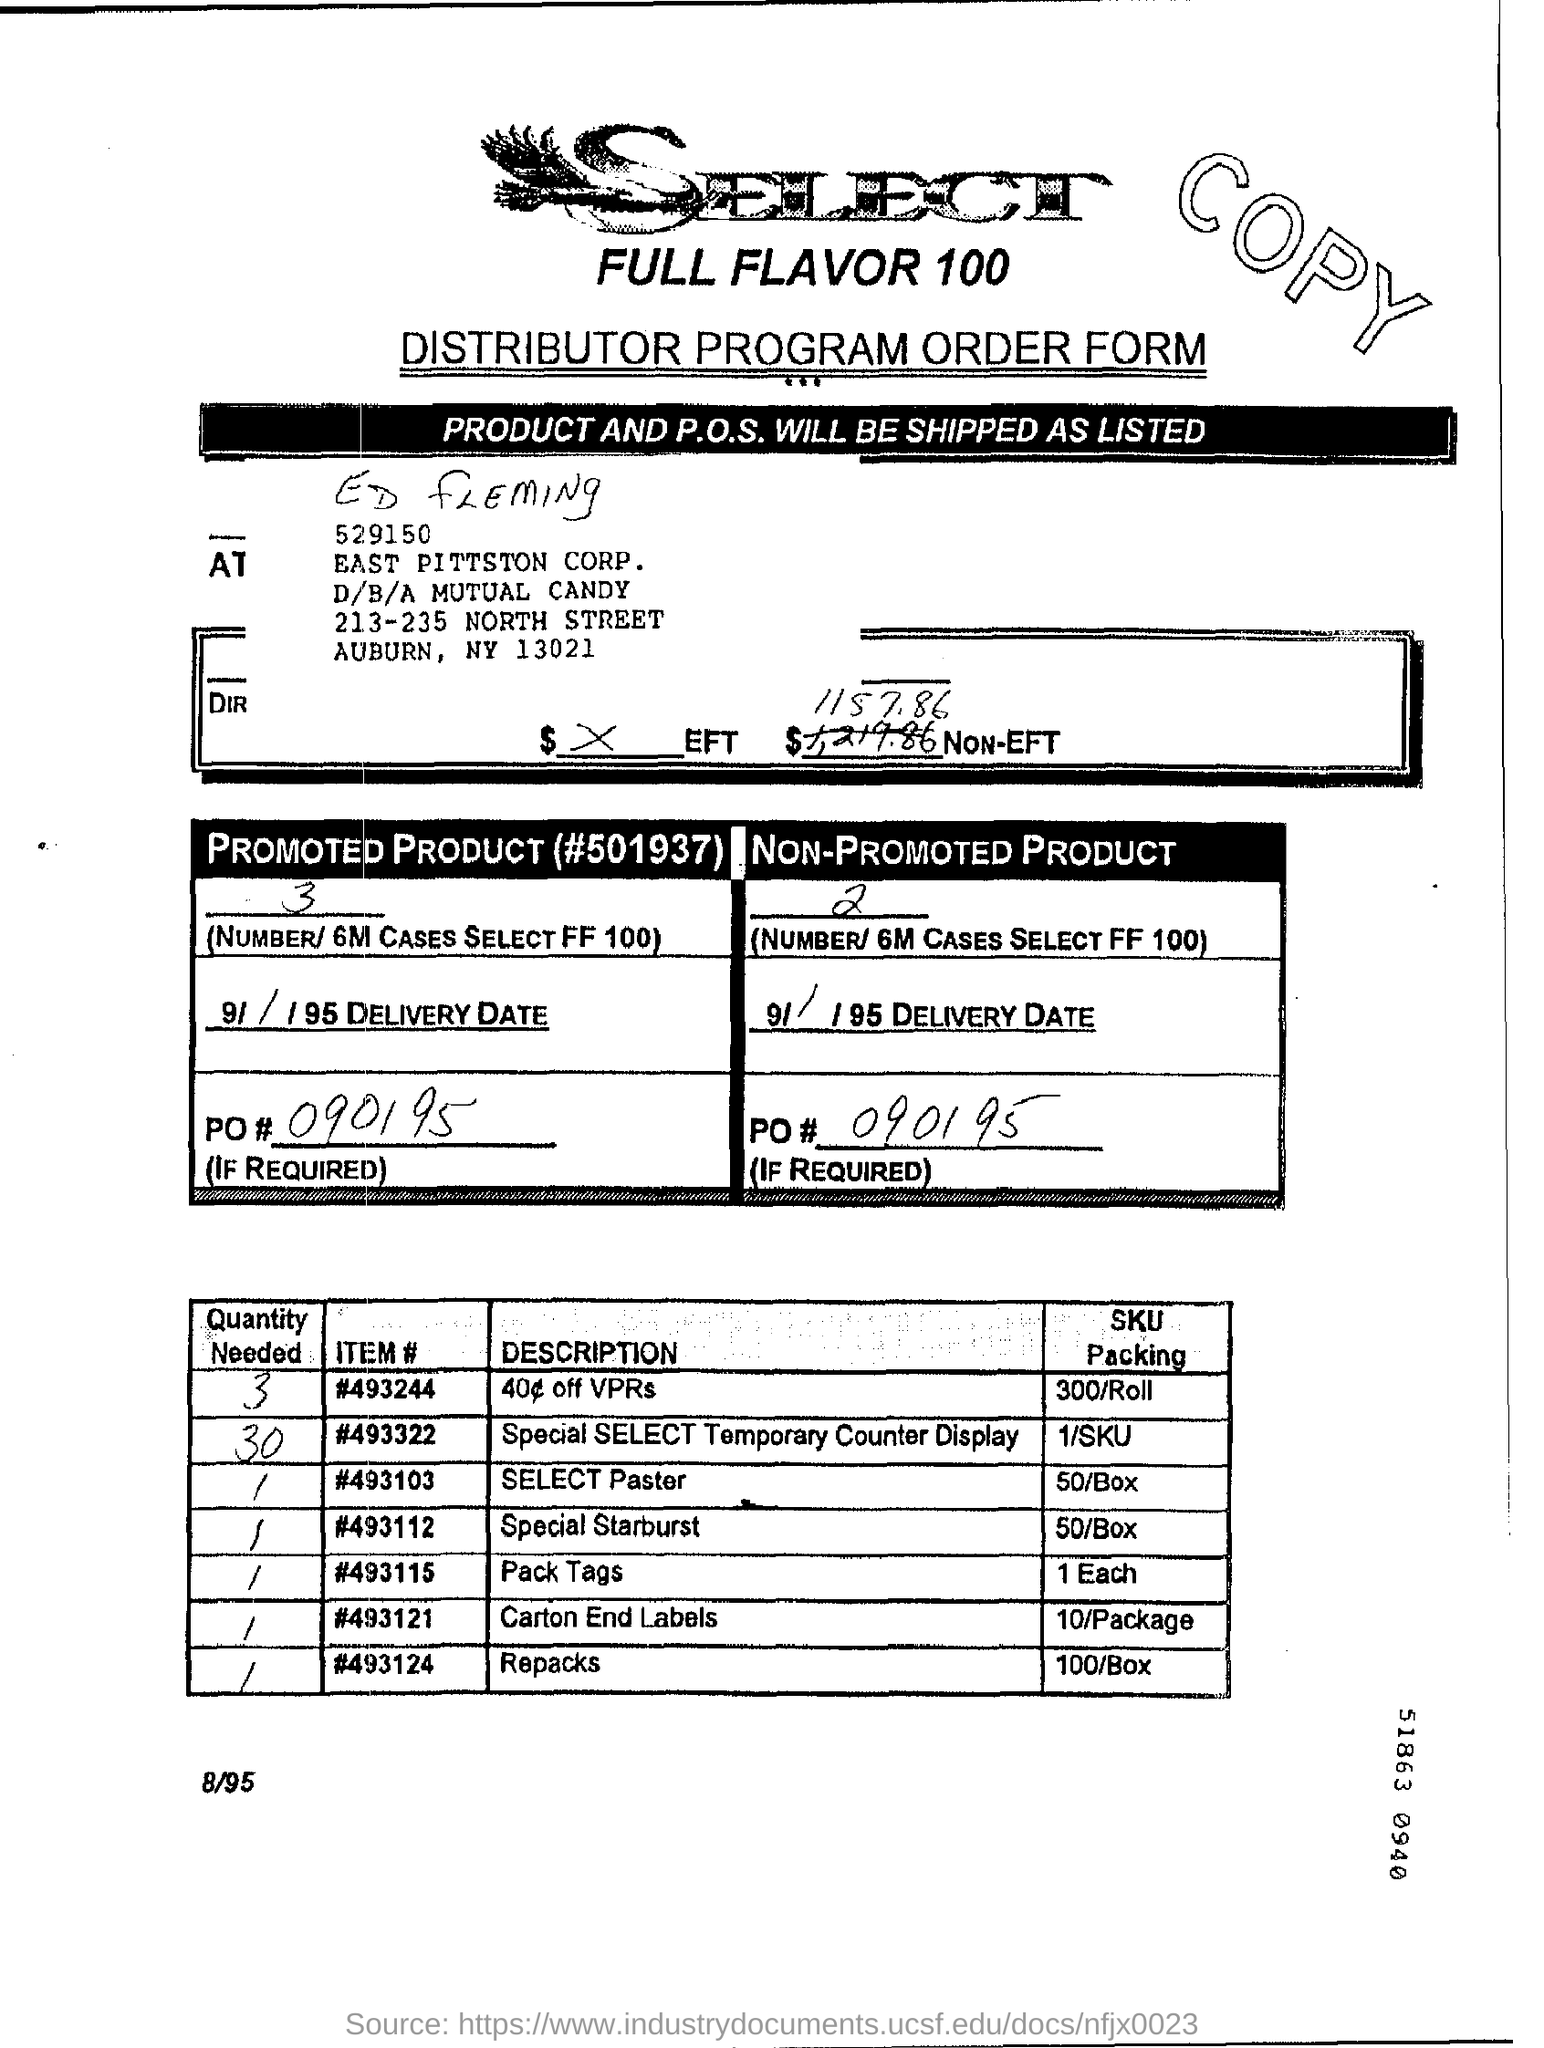List a handful of essential elements in this visual. This is a distributor program order form. What is the item number of the SELECT Paster from the second table? The pricing information for the SKU Packing for ITEM # 493121, which is sold in packs of 10, is available. The maximum value written in the "Quantity Needed" column of table 2 is 30. What is the required quantity for repacking based on the second table? 